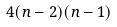<formula> <loc_0><loc_0><loc_500><loc_500>4 ( n - 2 ) ( n - 1 )</formula> 